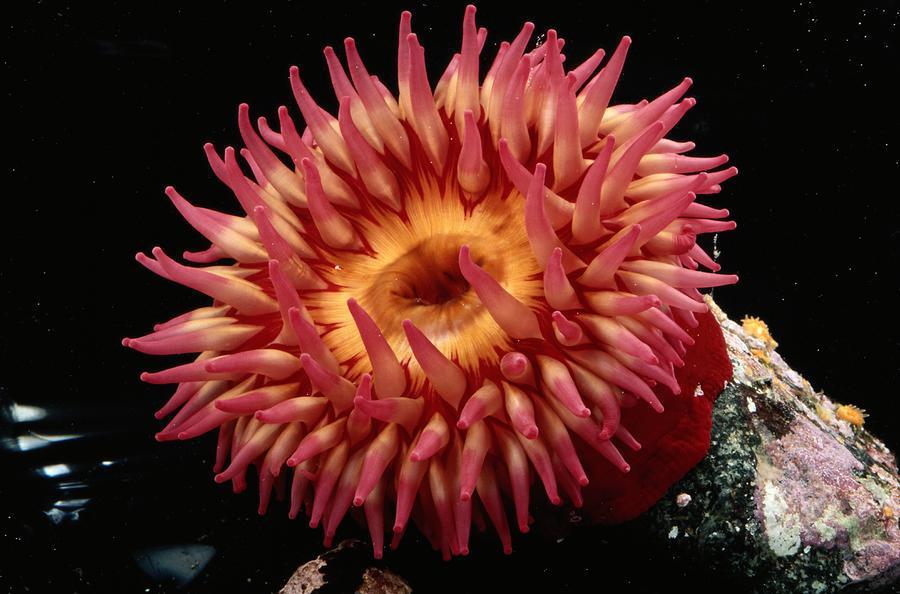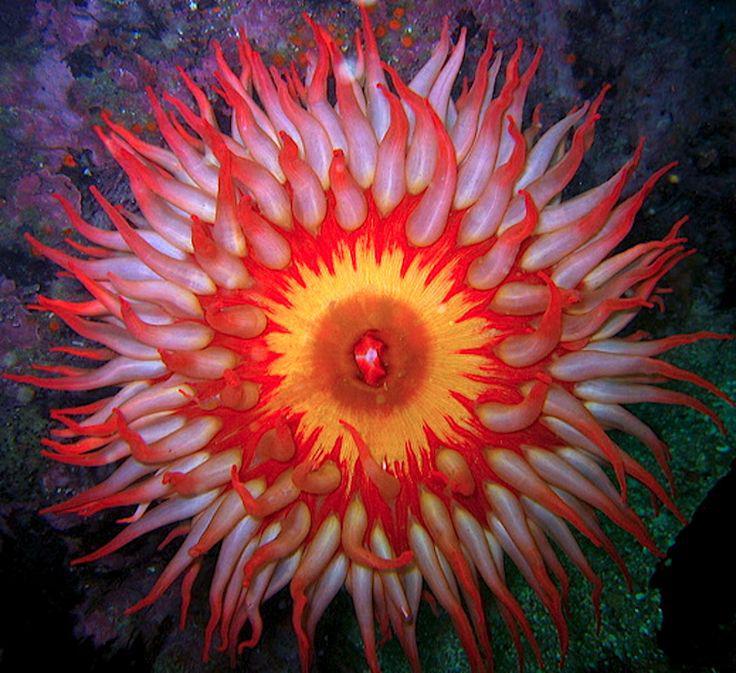The first image is the image on the left, the second image is the image on the right. Assess this claim about the two images: "There is no more than one pink anemone.". Correct or not? Answer yes or no. No. The first image is the image on the left, the second image is the image on the right. Assess this claim about the two images: "Both images show anemones with similar vibrant warm coloring.". Correct or not? Answer yes or no. Yes. 